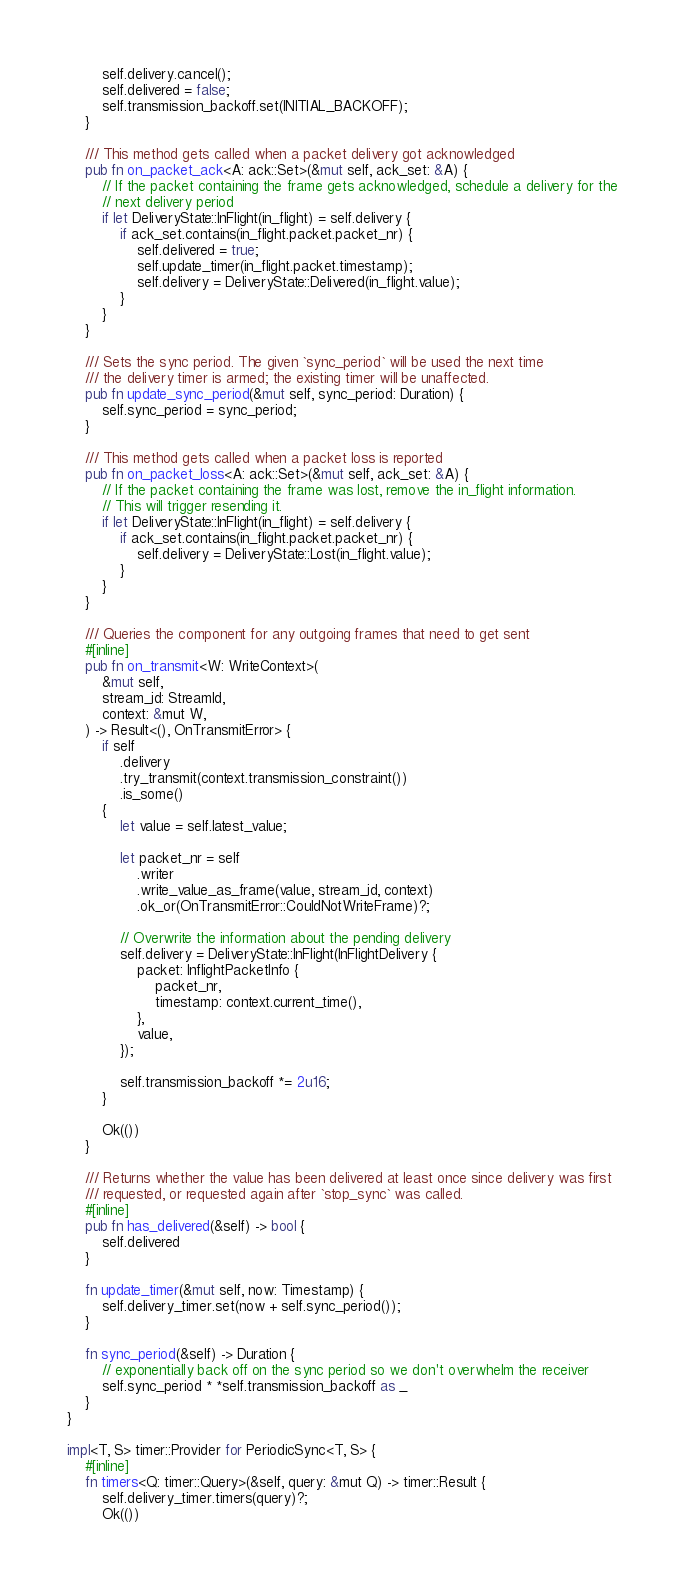<code> <loc_0><loc_0><loc_500><loc_500><_Rust_>        self.delivery.cancel();
        self.delivered = false;
        self.transmission_backoff.set(INITIAL_BACKOFF);
    }

    /// This method gets called when a packet delivery got acknowledged
    pub fn on_packet_ack<A: ack::Set>(&mut self, ack_set: &A) {
        // If the packet containing the frame gets acknowledged, schedule a delivery for the
        // next delivery period
        if let DeliveryState::InFlight(in_flight) = self.delivery {
            if ack_set.contains(in_flight.packet.packet_nr) {
                self.delivered = true;
                self.update_timer(in_flight.packet.timestamp);
                self.delivery = DeliveryState::Delivered(in_flight.value);
            }
        }
    }

    /// Sets the sync period. The given `sync_period` will be used the next time
    /// the delivery timer is armed; the existing timer will be unaffected.
    pub fn update_sync_period(&mut self, sync_period: Duration) {
        self.sync_period = sync_period;
    }

    /// This method gets called when a packet loss is reported
    pub fn on_packet_loss<A: ack::Set>(&mut self, ack_set: &A) {
        // If the packet containing the frame was lost, remove the in_flight information.
        // This will trigger resending it.
        if let DeliveryState::InFlight(in_flight) = self.delivery {
            if ack_set.contains(in_flight.packet.packet_nr) {
                self.delivery = DeliveryState::Lost(in_flight.value);
            }
        }
    }

    /// Queries the component for any outgoing frames that need to get sent
    #[inline]
    pub fn on_transmit<W: WriteContext>(
        &mut self,
        stream_id: StreamId,
        context: &mut W,
    ) -> Result<(), OnTransmitError> {
        if self
            .delivery
            .try_transmit(context.transmission_constraint())
            .is_some()
        {
            let value = self.latest_value;

            let packet_nr = self
                .writer
                .write_value_as_frame(value, stream_id, context)
                .ok_or(OnTransmitError::CouldNotWriteFrame)?;

            // Overwrite the information about the pending delivery
            self.delivery = DeliveryState::InFlight(InFlightDelivery {
                packet: InflightPacketInfo {
                    packet_nr,
                    timestamp: context.current_time(),
                },
                value,
            });

            self.transmission_backoff *= 2u16;
        }

        Ok(())
    }

    /// Returns whether the value has been delivered at least once since delivery was first
    /// requested, or requested again after `stop_sync` was called.
    #[inline]
    pub fn has_delivered(&self) -> bool {
        self.delivered
    }

    fn update_timer(&mut self, now: Timestamp) {
        self.delivery_timer.set(now + self.sync_period());
    }

    fn sync_period(&self) -> Duration {
        // exponentially back off on the sync period so we don't overwhelm the receiver
        self.sync_period * *self.transmission_backoff as _
    }
}

impl<T, S> timer::Provider for PeriodicSync<T, S> {
    #[inline]
    fn timers<Q: timer::Query>(&self, query: &mut Q) -> timer::Result {
        self.delivery_timer.timers(query)?;
        Ok(())</code> 